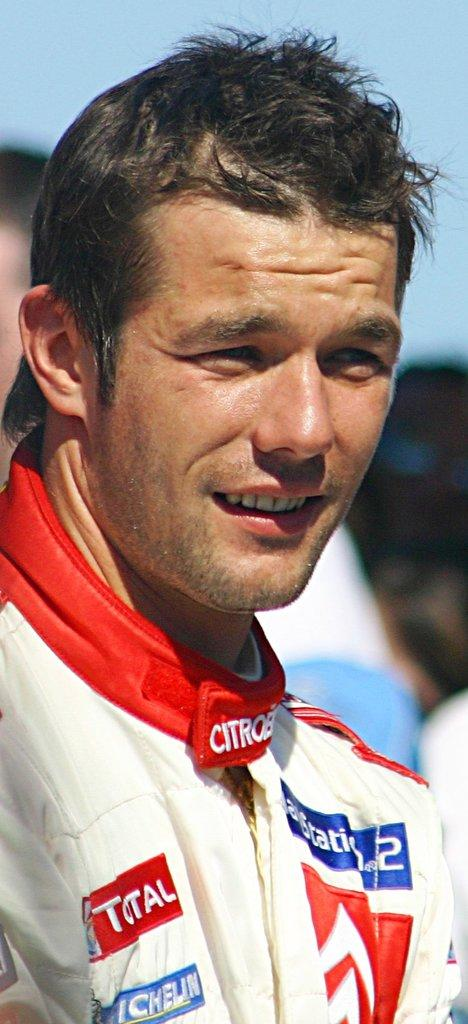Who or what is the main subject in the image? There is a person in the image. In which direction is the person facing? The person is facing towards the right. Can you describe the background of the image? The background of the image is blurred. What arithmetic problem is the person solving in the image? There is no arithmetic problem visible in the image, as it only features a person facing towards the right with a blurred background. 